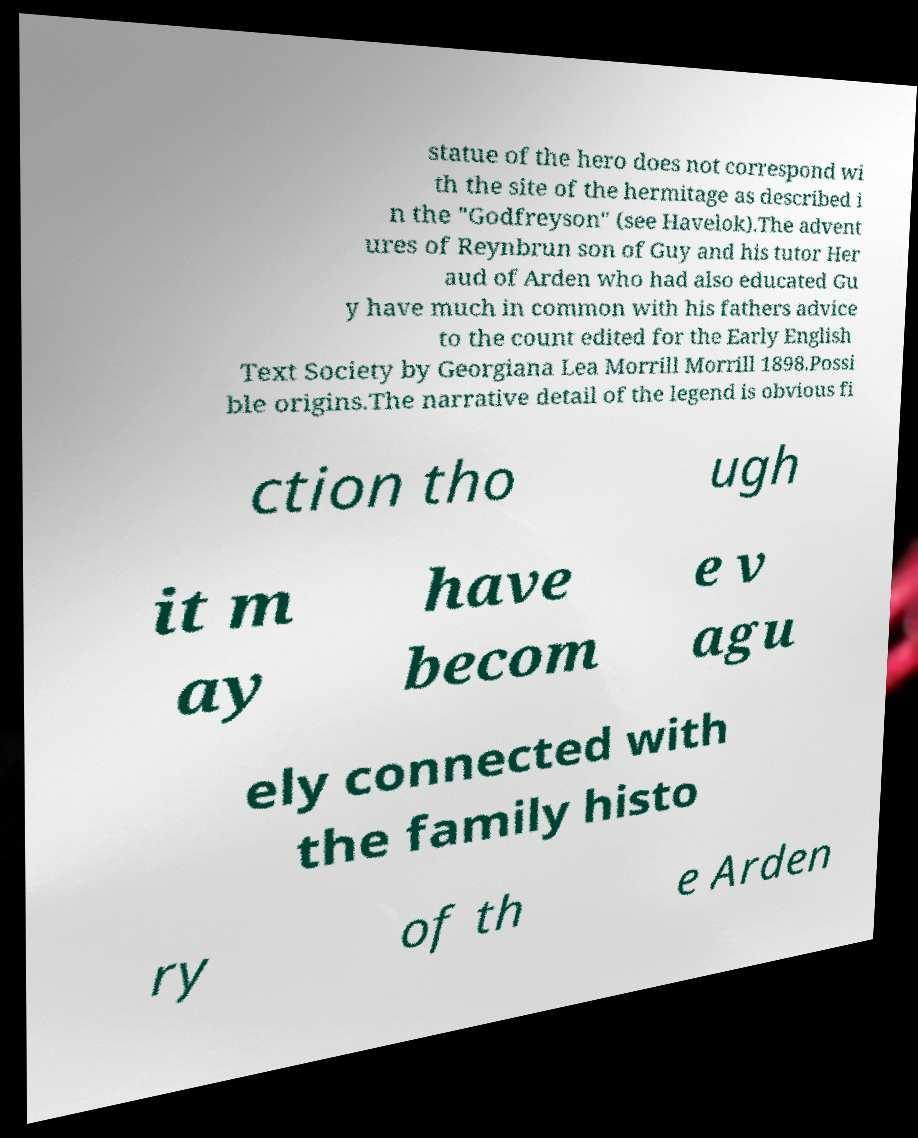Can you read and provide the text displayed in the image?This photo seems to have some interesting text. Can you extract and type it out for me? statue of the hero does not correspond wi th the site of the hermitage as described i n the "Godfreyson" (see Havelok).The advent ures of Reynbrun son of Guy and his tutor Her aud of Arden who had also educated Gu y have much in common with his fathers advice to the count edited for the Early English Text Society by Georgiana Lea Morrill Morrill 1898.Possi ble origins.The narrative detail of the legend is obvious fi ction tho ugh it m ay have becom e v agu ely connected with the family histo ry of th e Arden 